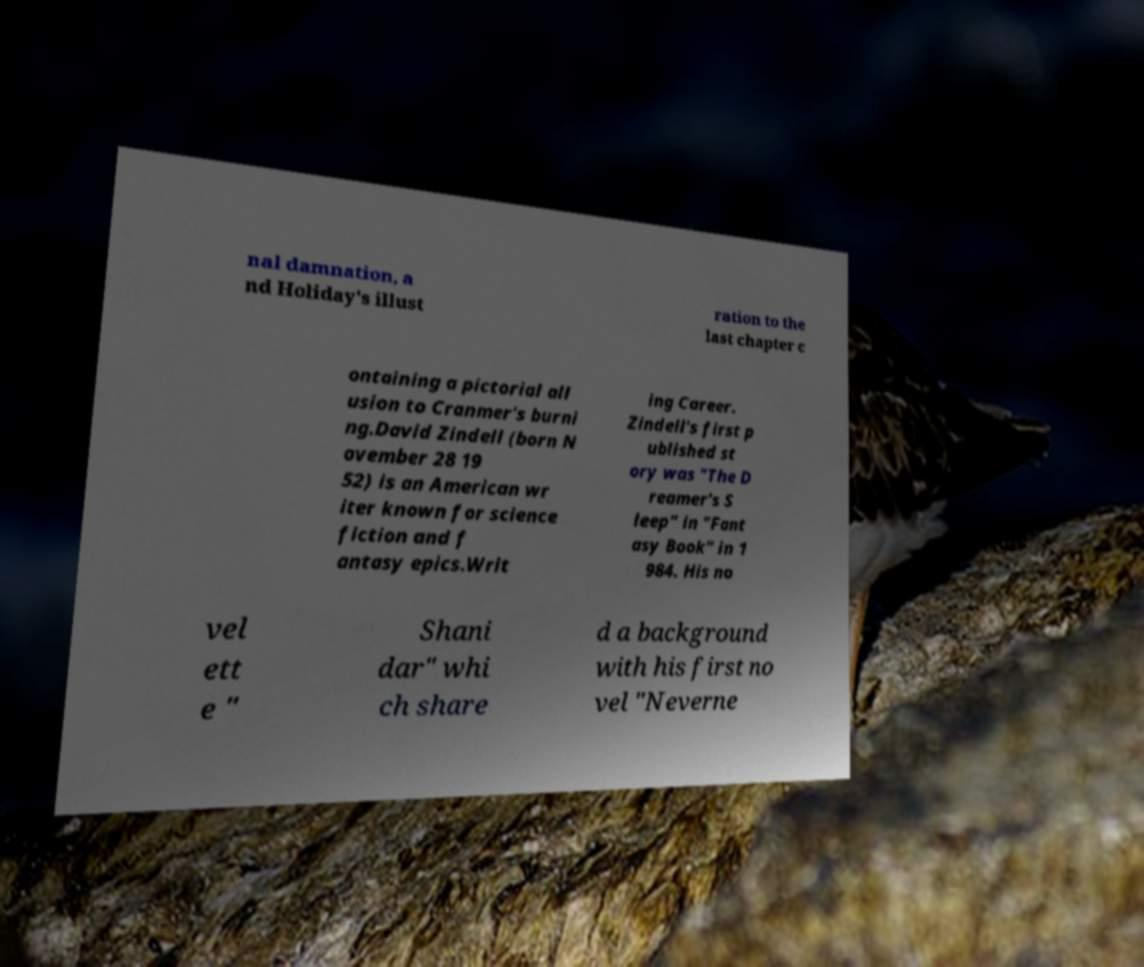I need the written content from this picture converted into text. Can you do that? nal damnation, a nd Holiday's illust ration to the last chapter c ontaining a pictorial all usion to Cranmer's burni ng.David Zindell (born N ovember 28 19 52) is an American wr iter known for science fiction and f antasy epics.Writ ing Career. Zindell's first p ublished st ory was "The D reamer's S leep" in "Fant asy Book" in 1 984. His no vel ett e " Shani dar" whi ch share d a background with his first no vel "Neverne 